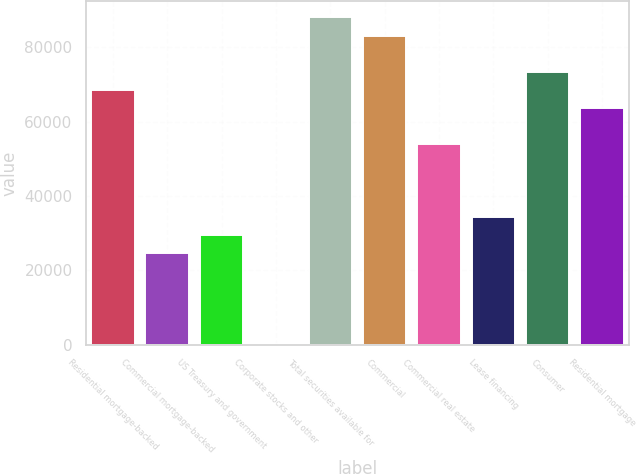Convert chart. <chart><loc_0><loc_0><loc_500><loc_500><bar_chart><fcel>Residential mortgage-backed<fcel>Commercial mortgage-backed<fcel>US Treasury and government<fcel>Corporate stocks and other<fcel>Total securities available for<fcel>Commercial<fcel>Commercial real estate<fcel>Lease financing<fcel>Consumer<fcel>Residential mortgage<nl><fcel>68486.2<fcel>24617.5<fcel>29491.8<fcel>246<fcel>87983.4<fcel>83109.1<fcel>53863.3<fcel>34366.1<fcel>73360.5<fcel>63611.9<nl></chart> 